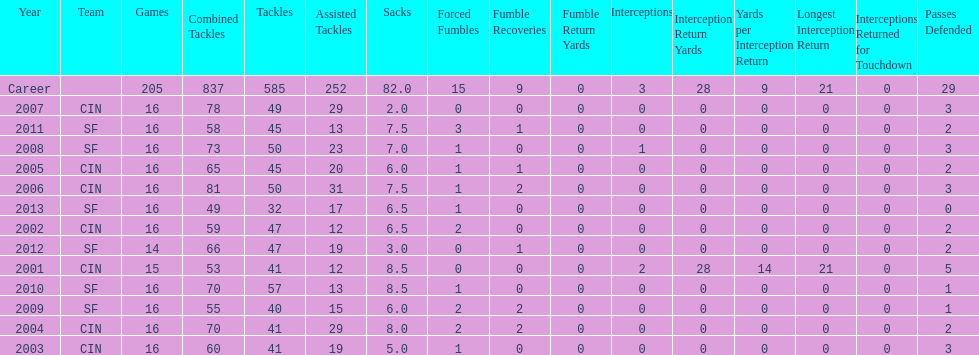How many consecutive seasons has he played sixteen games? 10. 